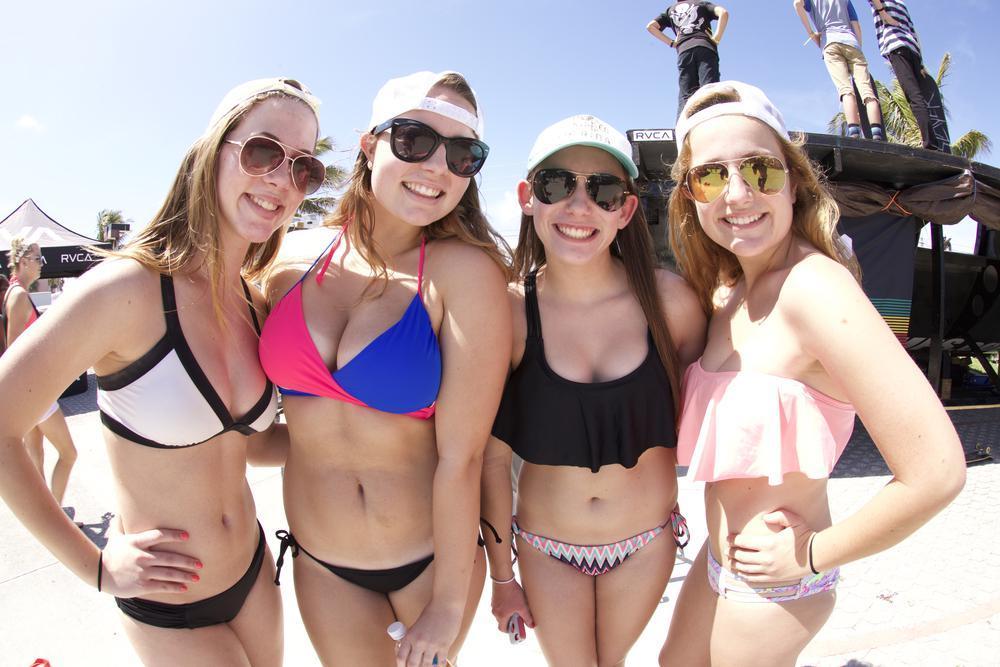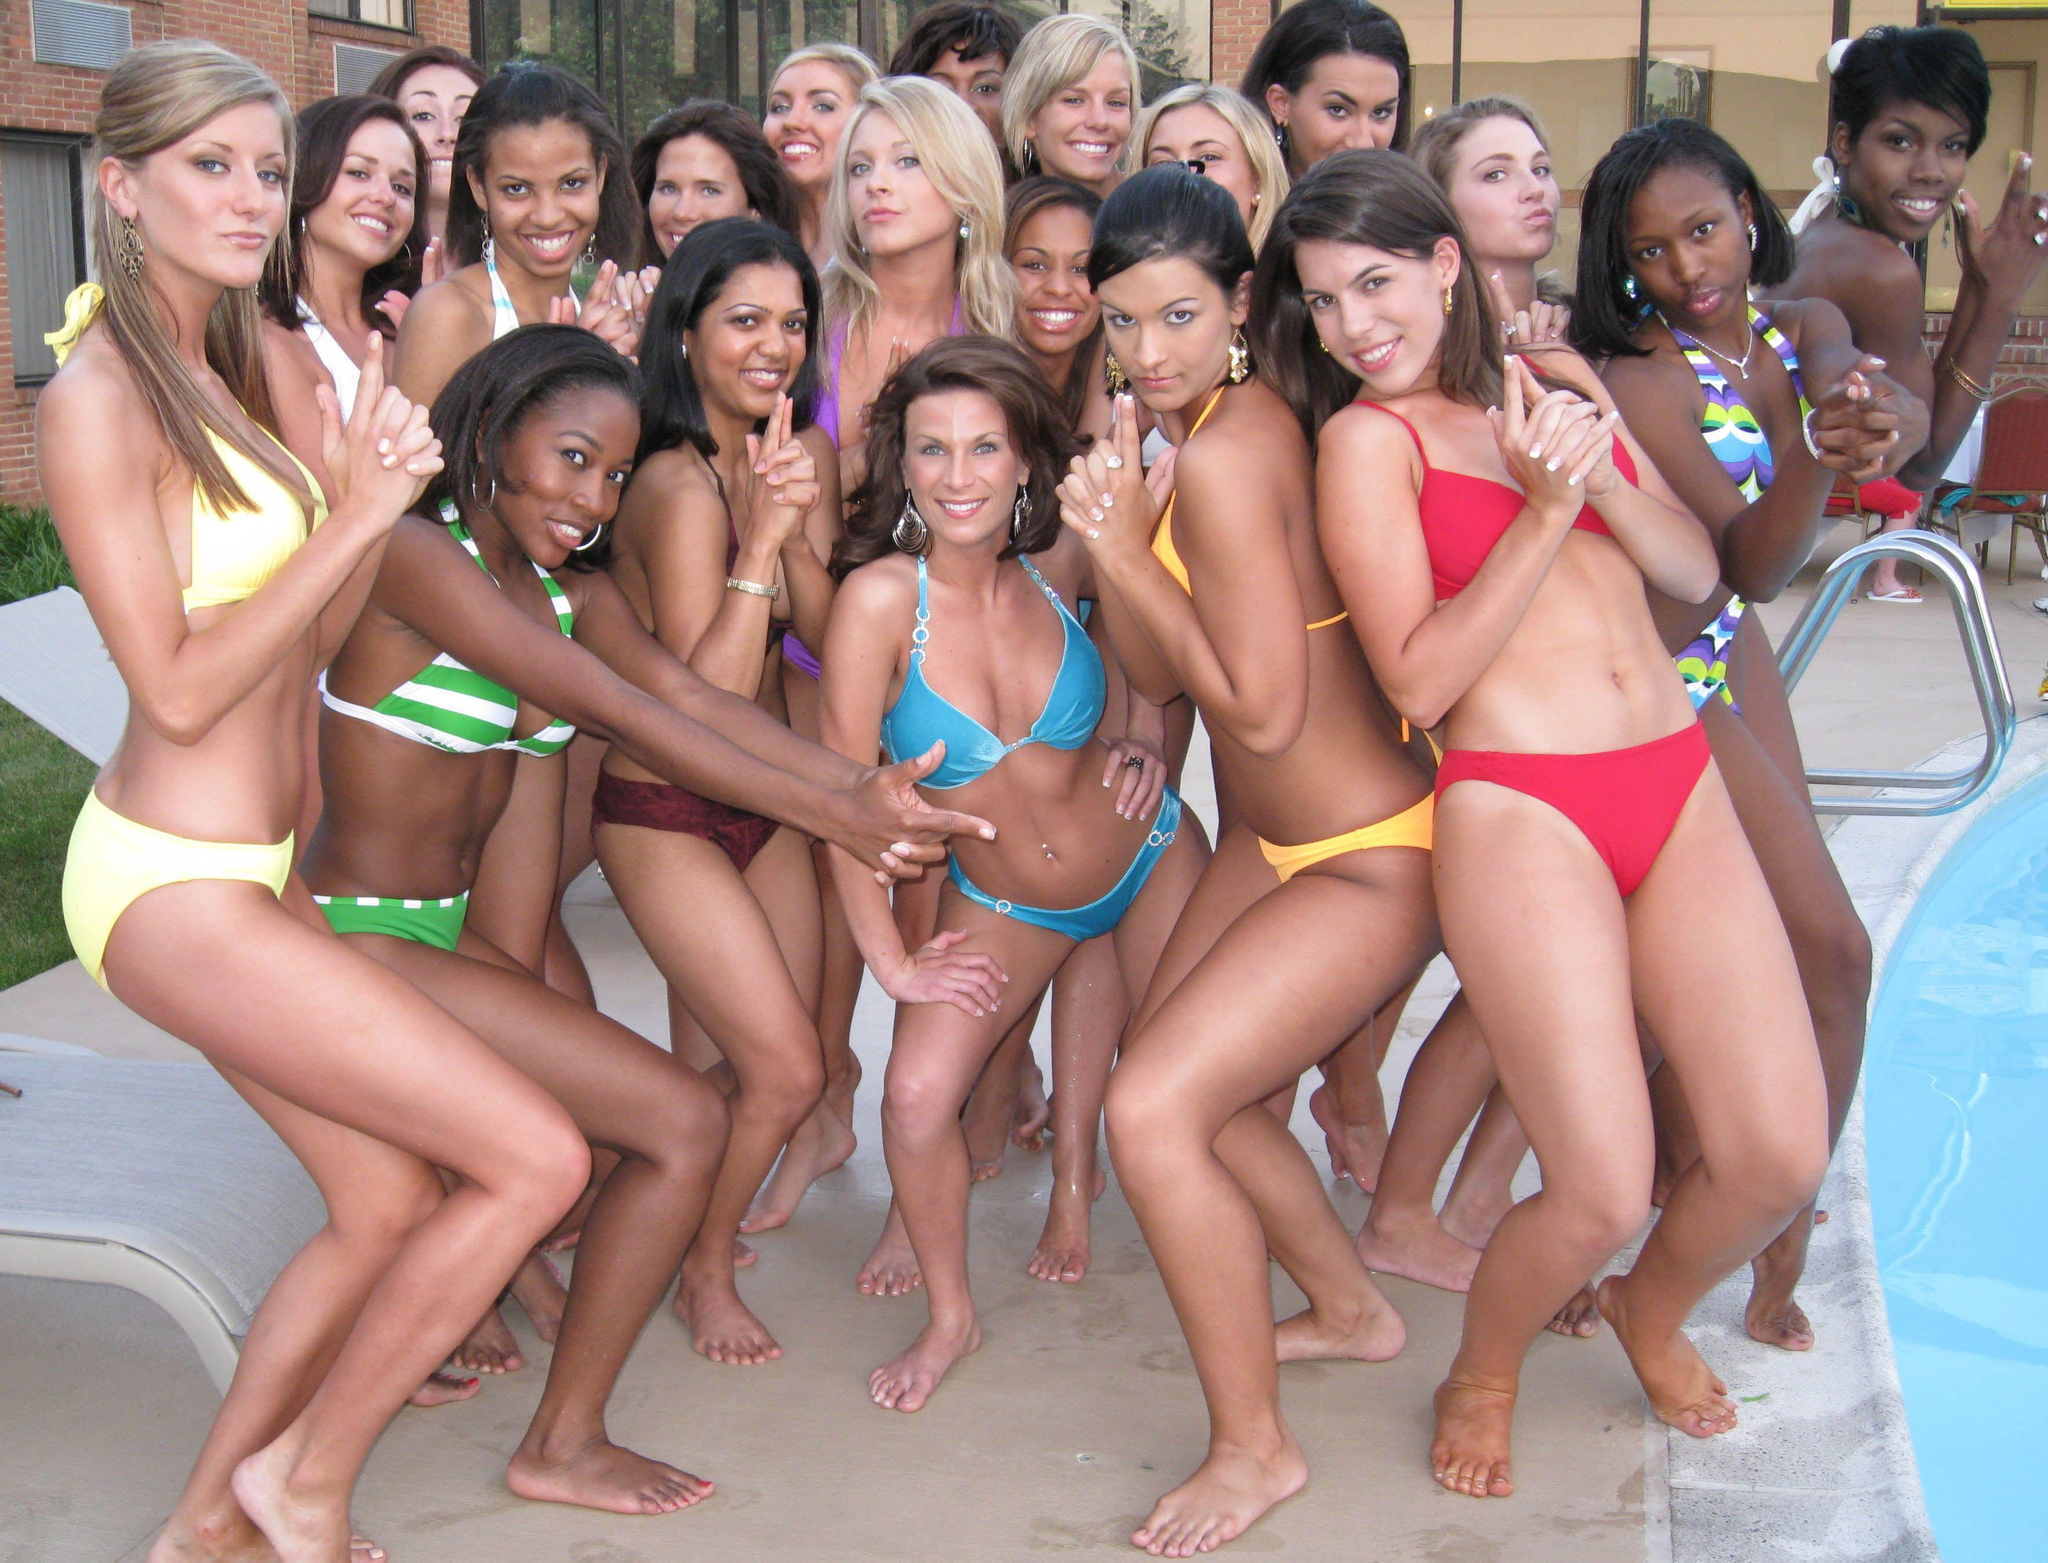The first image is the image on the left, the second image is the image on the right. Given the left and right images, does the statement "The women in the right image are wearing matching bikinis." hold true? Answer yes or no. No. 